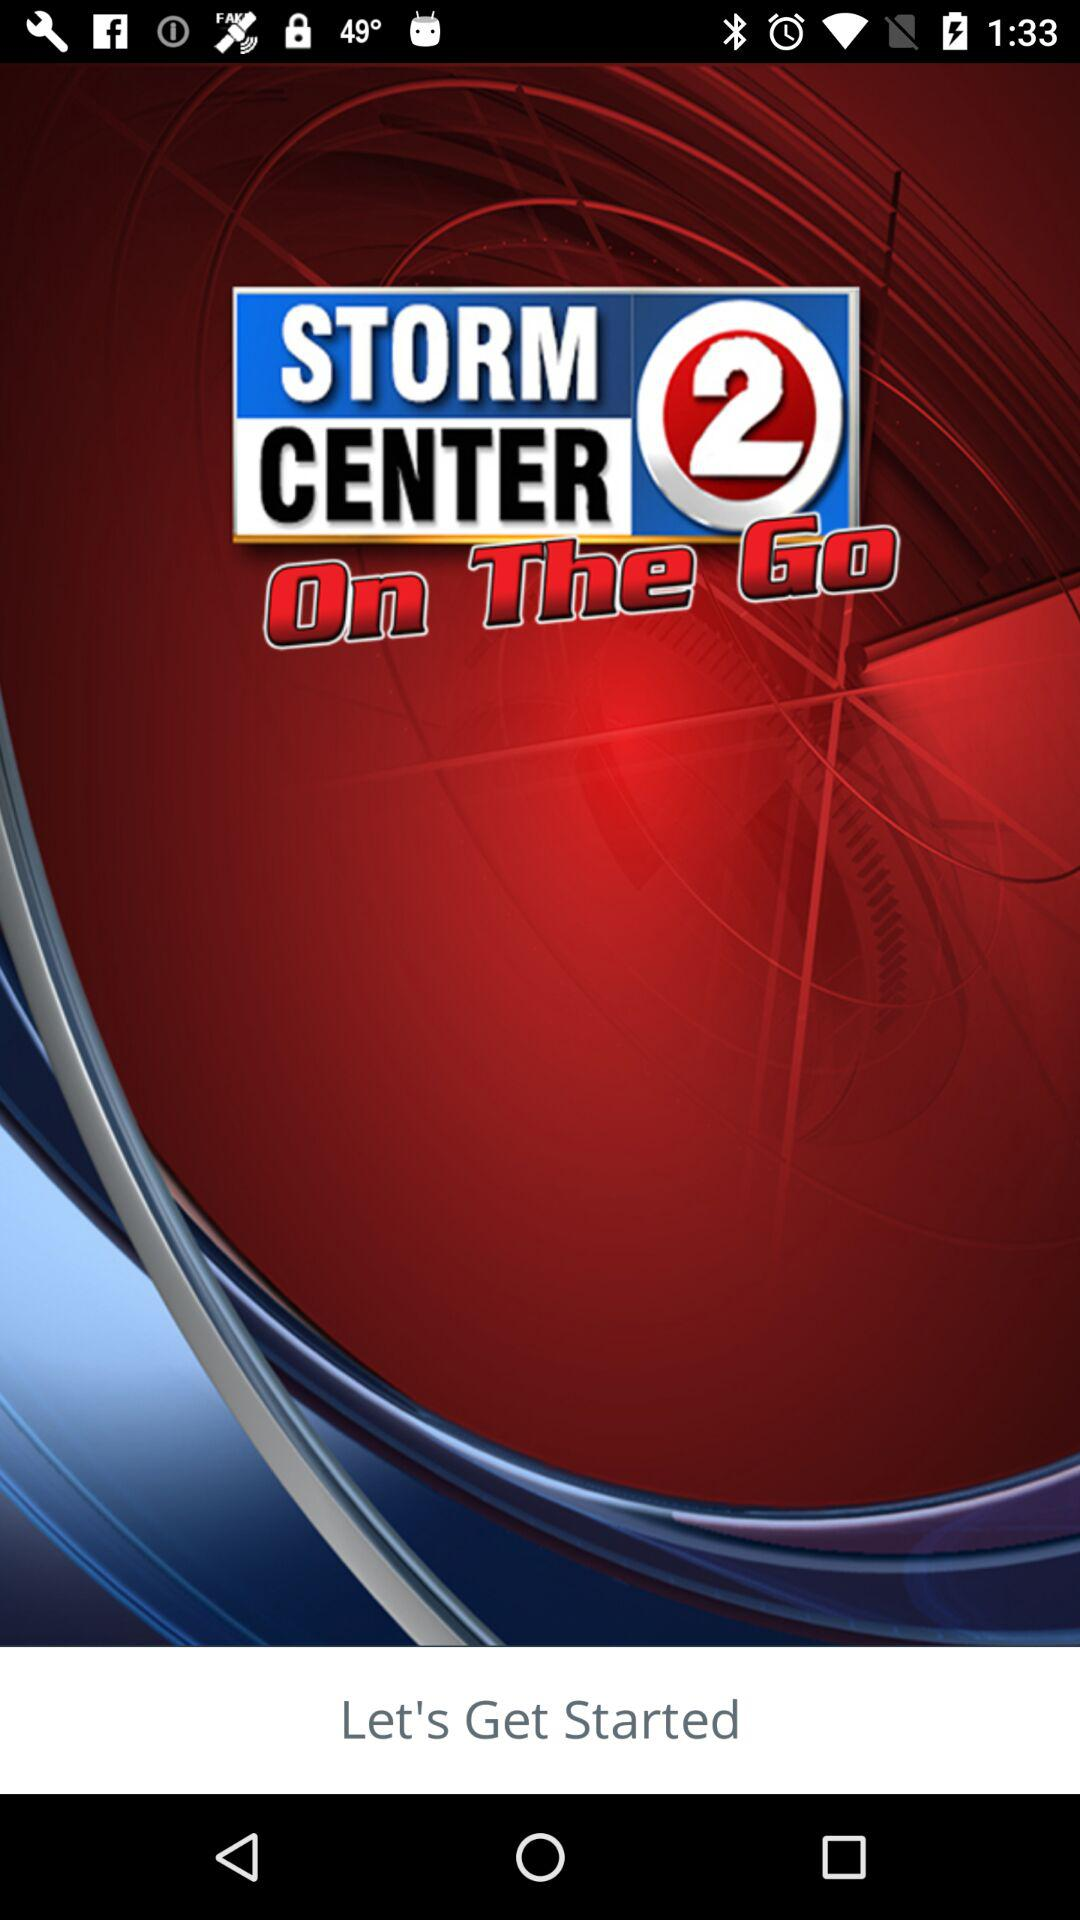What is the name of the application? The name of the application is "WBAY WEATHER - StormCenter 2". 